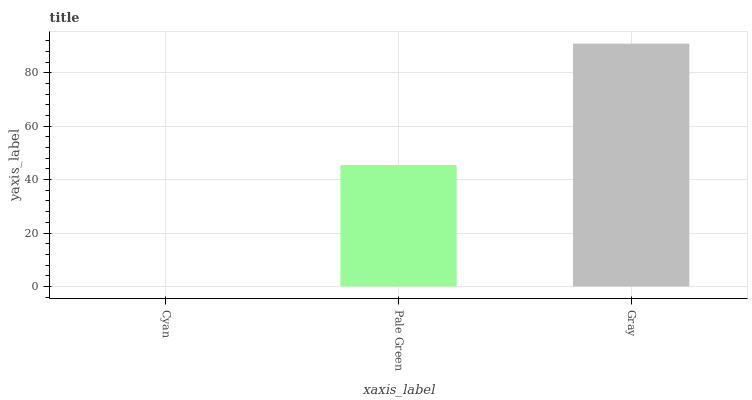Is Pale Green the minimum?
Answer yes or no. No. Is Pale Green the maximum?
Answer yes or no. No. Is Pale Green greater than Cyan?
Answer yes or no. Yes. Is Cyan less than Pale Green?
Answer yes or no. Yes. Is Cyan greater than Pale Green?
Answer yes or no. No. Is Pale Green less than Cyan?
Answer yes or no. No. Is Pale Green the high median?
Answer yes or no. Yes. Is Pale Green the low median?
Answer yes or no. Yes. Is Cyan the high median?
Answer yes or no. No. Is Gray the low median?
Answer yes or no. No. 